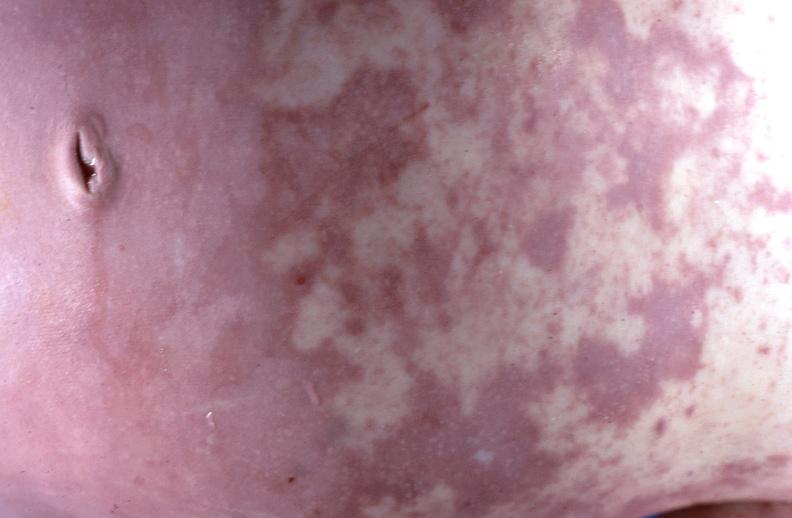does acute lymphocytic leukemia show gram negative septicemia due to scalp electrode in a neonate?
Answer the question using a single word or phrase. No 